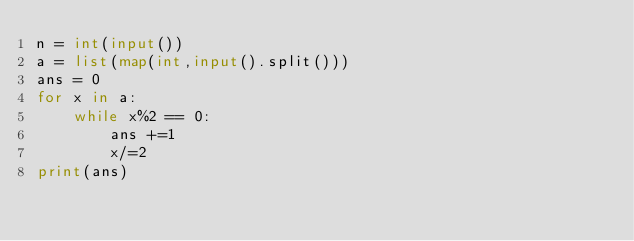<code> <loc_0><loc_0><loc_500><loc_500><_Python_>n = int(input())
a = list(map(int,input().split()))
ans = 0
for x in a:
    while x%2 == 0:
        ans +=1
        x/=2
print(ans)</code> 